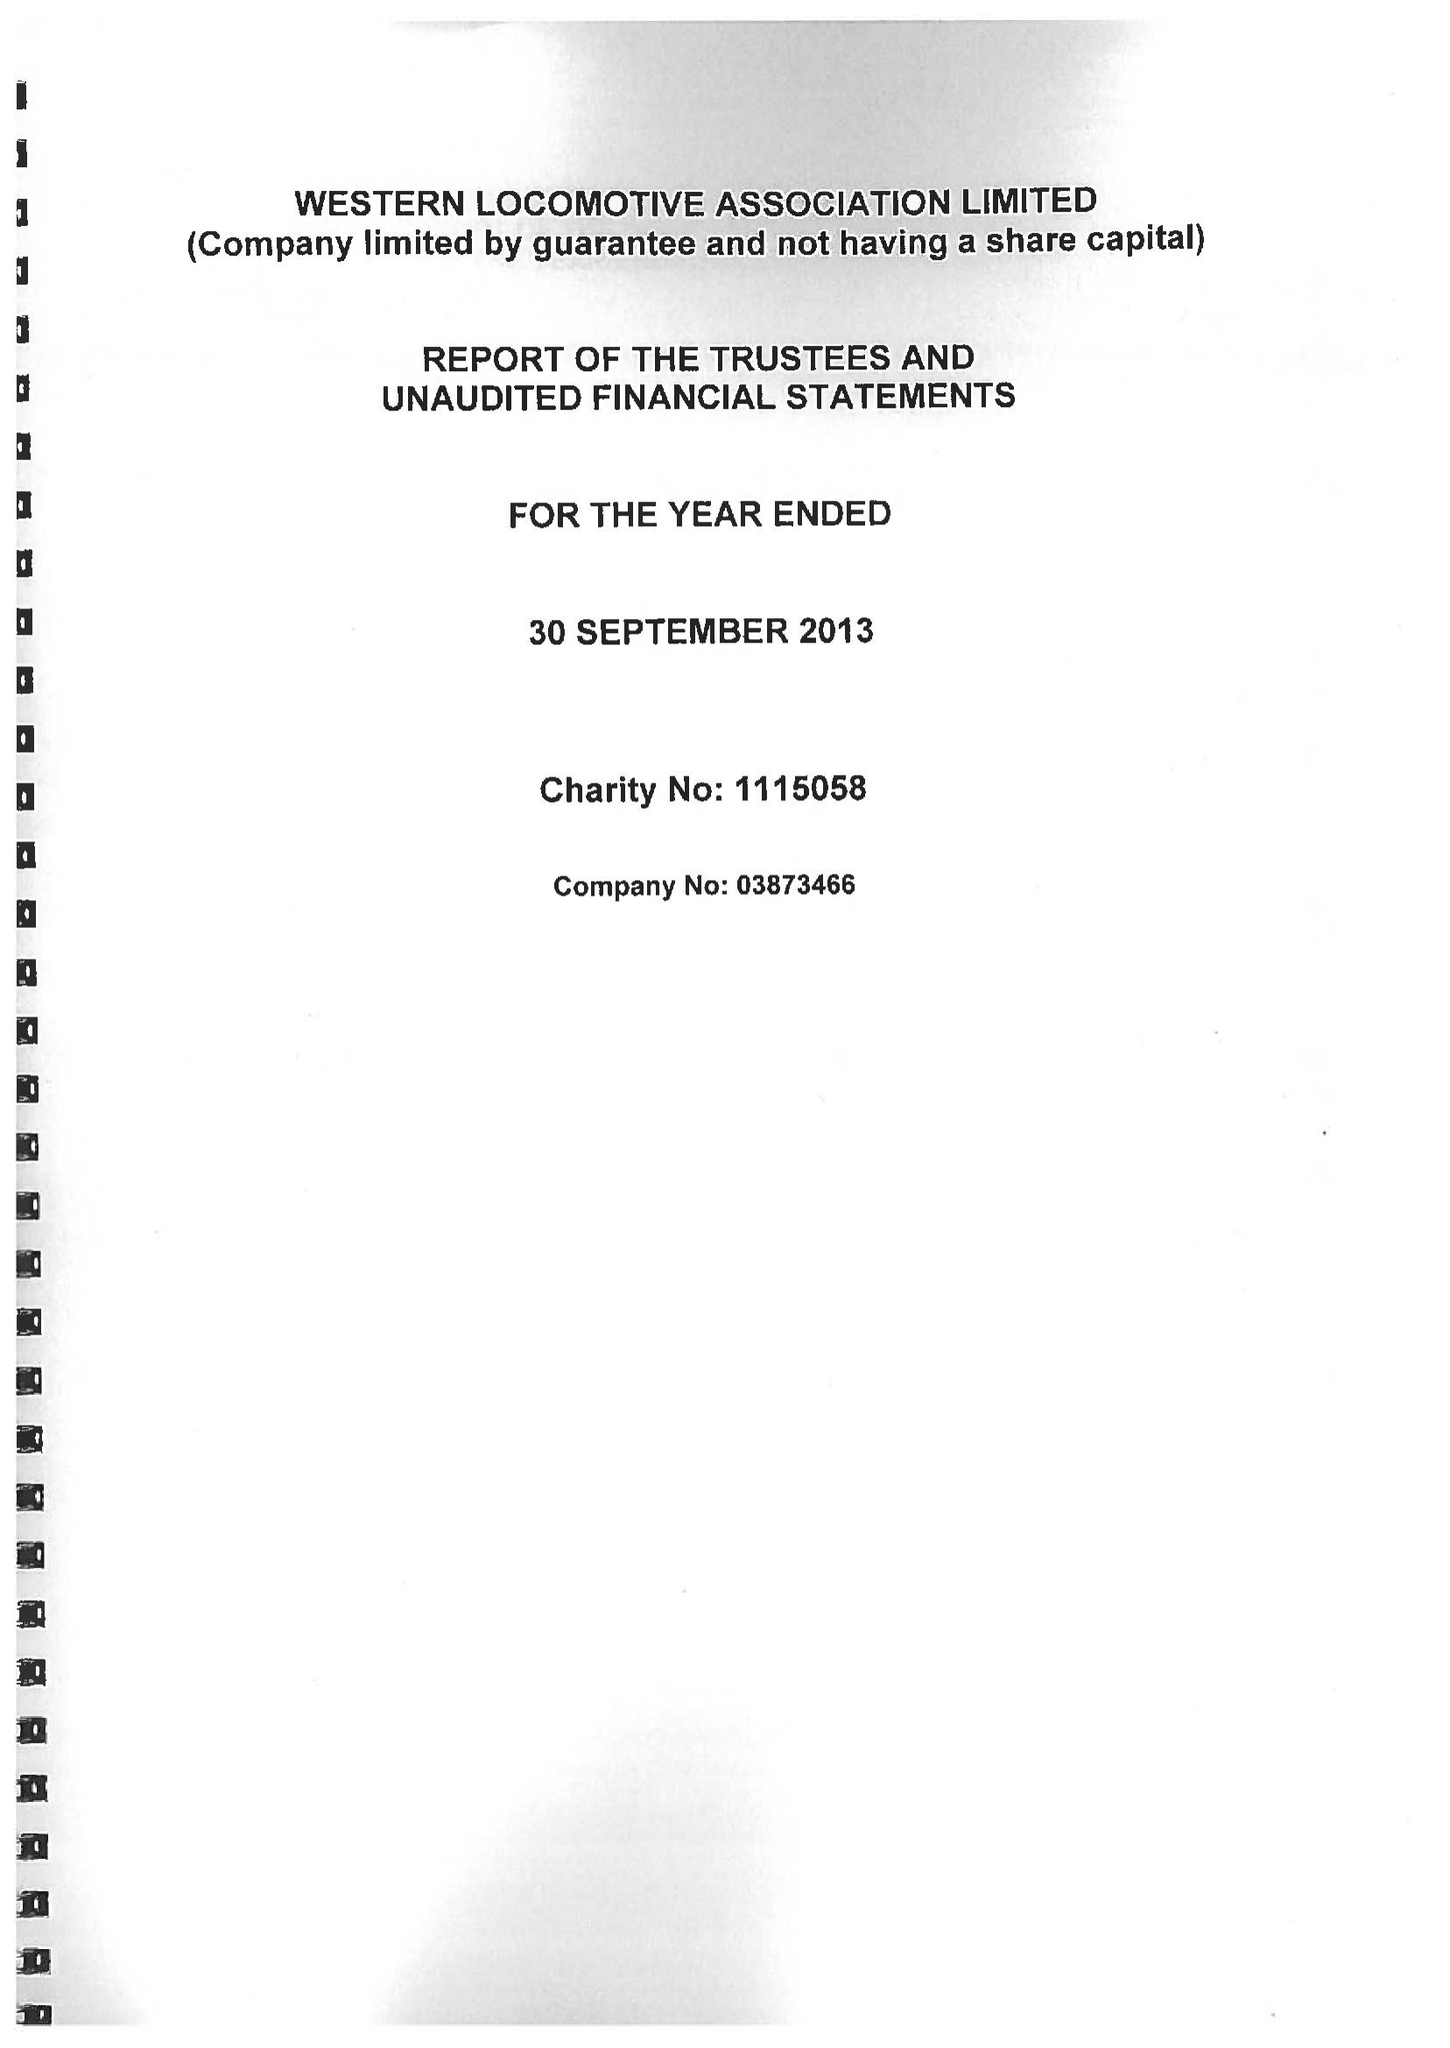What is the value for the address__postcode?
Answer the question using a single word or phrase. ST17 0BS 